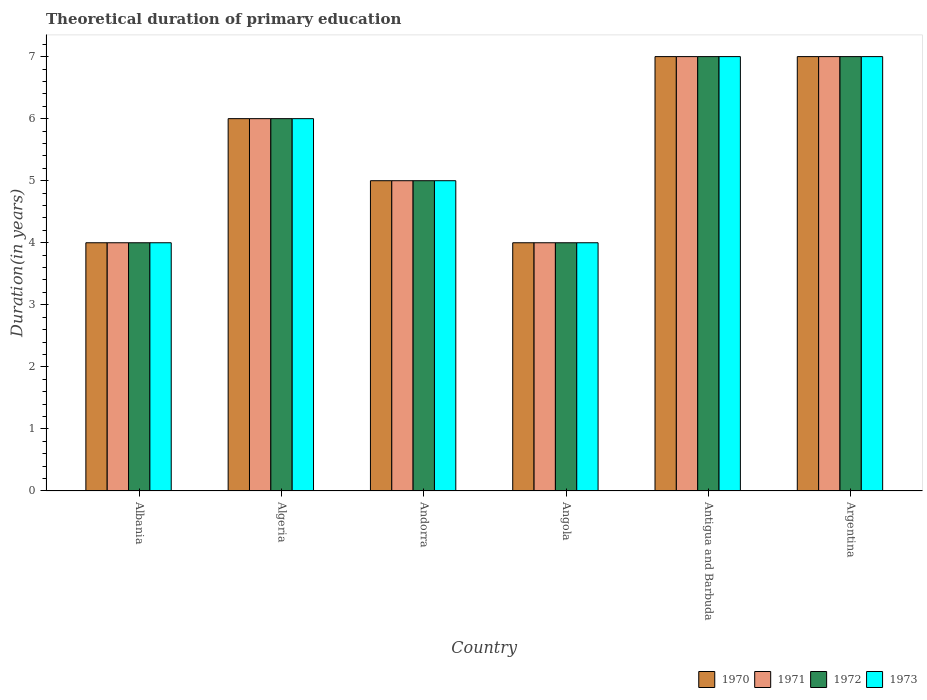How many different coloured bars are there?
Your answer should be compact. 4. Are the number of bars per tick equal to the number of legend labels?
Provide a succinct answer. Yes. How many bars are there on the 6th tick from the left?
Your response must be concise. 4. How many bars are there on the 5th tick from the right?
Your answer should be compact. 4. What is the label of the 2nd group of bars from the left?
Offer a very short reply. Algeria. Across all countries, what is the maximum total theoretical duration of primary education in 1971?
Offer a very short reply. 7. In which country was the total theoretical duration of primary education in 1972 maximum?
Provide a short and direct response. Antigua and Barbuda. In which country was the total theoretical duration of primary education in 1972 minimum?
Offer a terse response. Albania. What is the difference between the total theoretical duration of primary education in 1970 in Argentina and the total theoretical duration of primary education in 1972 in Algeria?
Your answer should be compact. 1. In how many countries, is the total theoretical duration of primary education in 1972 greater than 6.8 years?
Provide a succinct answer. 2. What is the ratio of the total theoretical duration of primary education in 1973 in Algeria to that in Antigua and Barbuda?
Offer a very short reply. 0.86. Is the total theoretical duration of primary education in 1973 in Albania less than that in Argentina?
Ensure brevity in your answer.  Yes. Is the difference between the total theoretical duration of primary education in 1971 in Albania and Argentina greater than the difference between the total theoretical duration of primary education in 1970 in Albania and Argentina?
Provide a short and direct response. No. What is the difference between the highest and the second highest total theoretical duration of primary education in 1970?
Ensure brevity in your answer.  -1. What is the difference between the highest and the lowest total theoretical duration of primary education in 1973?
Make the answer very short. 3. Is the sum of the total theoretical duration of primary education in 1973 in Algeria and Antigua and Barbuda greater than the maximum total theoretical duration of primary education in 1971 across all countries?
Offer a terse response. Yes. What does the 1st bar from the left in Albania represents?
Your response must be concise. 1970. What does the 2nd bar from the right in Argentina represents?
Make the answer very short. 1972. How many bars are there?
Your answer should be compact. 24. Are all the bars in the graph horizontal?
Provide a short and direct response. No. What is the difference between two consecutive major ticks on the Y-axis?
Make the answer very short. 1. Are the values on the major ticks of Y-axis written in scientific E-notation?
Offer a terse response. No. Where does the legend appear in the graph?
Keep it short and to the point. Bottom right. How many legend labels are there?
Make the answer very short. 4. How are the legend labels stacked?
Provide a succinct answer. Horizontal. What is the title of the graph?
Your response must be concise. Theoretical duration of primary education. What is the label or title of the X-axis?
Provide a short and direct response. Country. What is the label or title of the Y-axis?
Offer a very short reply. Duration(in years). What is the Duration(in years) in 1970 in Albania?
Your answer should be compact. 4. What is the Duration(in years) of 1971 in Albania?
Keep it short and to the point. 4. What is the Duration(in years) in 1973 in Albania?
Offer a terse response. 4. What is the Duration(in years) in 1972 in Algeria?
Offer a terse response. 6. What is the Duration(in years) of 1973 in Algeria?
Keep it short and to the point. 6. What is the Duration(in years) in 1971 in Andorra?
Make the answer very short. 5. What is the Duration(in years) of 1972 in Andorra?
Offer a very short reply. 5. What is the Duration(in years) of 1970 in Angola?
Make the answer very short. 4. What is the Duration(in years) in 1972 in Angola?
Give a very brief answer. 4. What is the Duration(in years) in 1973 in Angola?
Your answer should be compact. 4. What is the Duration(in years) of 1971 in Antigua and Barbuda?
Provide a succinct answer. 7. What is the Duration(in years) in 1970 in Argentina?
Offer a very short reply. 7. What is the Duration(in years) in 1973 in Argentina?
Make the answer very short. 7. Across all countries, what is the maximum Duration(in years) in 1973?
Make the answer very short. 7. Across all countries, what is the minimum Duration(in years) of 1971?
Keep it short and to the point. 4. What is the total Duration(in years) of 1970 in the graph?
Your answer should be compact. 33. What is the total Duration(in years) in 1973 in the graph?
Offer a terse response. 33. What is the difference between the Duration(in years) in 1970 in Albania and that in Algeria?
Make the answer very short. -2. What is the difference between the Duration(in years) of 1971 in Albania and that in Algeria?
Your answer should be compact. -2. What is the difference between the Duration(in years) in 1972 in Albania and that in Algeria?
Give a very brief answer. -2. What is the difference between the Duration(in years) in 1973 in Albania and that in Algeria?
Your answer should be very brief. -2. What is the difference between the Duration(in years) in 1970 in Albania and that in Andorra?
Make the answer very short. -1. What is the difference between the Duration(in years) of 1973 in Albania and that in Andorra?
Your response must be concise. -1. What is the difference between the Duration(in years) in 1971 in Albania and that in Angola?
Your response must be concise. 0. What is the difference between the Duration(in years) in 1971 in Albania and that in Antigua and Barbuda?
Your answer should be compact. -3. What is the difference between the Duration(in years) of 1972 in Albania and that in Antigua and Barbuda?
Offer a terse response. -3. What is the difference between the Duration(in years) in 1971 in Albania and that in Argentina?
Provide a short and direct response. -3. What is the difference between the Duration(in years) in 1970 in Algeria and that in Andorra?
Offer a terse response. 1. What is the difference between the Duration(in years) of 1972 in Algeria and that in Andorra?
Offer a terse response. 1. What is the difference between the Duration(in years) of 1970 in Algeria and that in Angola?
Ensure brevity in your answer.  2. What is the difference between the Duration(in years) of 1970 in Algeria and that in Antigua and Barbuda?
Provide a short and direct response. -1. What is the difference between the Duration(in years) in 1972 in Algeria and that in Antigua and Barbuda?
Keep it short and to the point. -1. What is the difference between the Duration(in years) in 1973 in Algeria and that in Antigua and Barbuda?
Your answer should be compact. -1. What is the difference between the Duration(in years) in 1970 in Algeria and that in Argentina?
Your response must be concise. -1. What is the difference between the Duration(in years) of 1971 in Algeria and that in Argentina?
Make the answer very short. -1. What is the difference between the Duration(in years) of 1972 in Algeria and that in Argentina?
Make the answer very short. -1. What is the difference between the Duration(in years) in 1972 in Andorra and that in Angola?
Make the answer very short. 1. What is the difference between the Duration(in years) of 1970 in Andorra and that in Antigua and Barbuda?
Keep it short and to the point. -2. What is the difference between the Duration(in years) of 1972 in Andorra and that in Antigua and Barbuda?
Offer a terse response. -2. What is the difference between the Duration(in years) in 1973 in Andorra and that in Antigua and Barbuda?
Your answer should be very brief. -2. What is the difference between the Duration(in years) of 1971 in Andorra and that in Argentina?
Keep it short and to the point. -2. What is the difference between the Duration(in years) in 1972 in Andorra and that in Argentina?
Offer a very short reply. -2. What is the difference between the Duration(in years) in 1970 in Angola and that in Antigua and Barbuda?
Your response must be concise. -3. What is the difference between the Duration(in years) in 1973 in Angola and that in Antigua and Barbuda?
Your answer should be very brief. -3. What is the difference between the Duration(in years) of 1971 in Angola and that in Argentina?
Keep it short and to the point. -3. What is the difference between the Duration(in years) of 1972 in Angola and that in Argentina?
Ensure brevity in your answer.  -3. What is the difference between the Duration(in years) of 1973 in Angola and that in Argentina?
Give a very brief answer. -3. What is the difference between the Duration(in years) in 1972 in Albania and the Duration(in years) in 1973 in Algeria?
Your answer should be compact. -2. What is the difference between the Duration(in years) in 1970 in Albania and the Duration(in years) in 1971 in Andorra?
Make the answer very short. -1. What is the difference between the Duration(in years) in 1971 in Albania and the Duration(in years) in 1972 in Andorra?
Make the answer very short. -1. What is the difference between the Duration(in years) of 1970 in Albania and the Duration(in years) of 1972 in Angola?
Ensure brevity in your answer.  0. What is the difference between the Duration(in years) of 1971 in Albania and the Duration(in years) of 1973 in Angola?
Offer a very short reply. 0. What is the difference between the Duration(in years) in 1972 in Albania and the Duration(in years) in 1973 in Angola?
Your answer should be compact. 0. What is the difference between the Duration(in years) of 1970 in Albania and the Duration(in years) of 1971 in Antigua and Barbuda?
Offer a very short reply. -3. What is the difference between the Duration(in years) of 1970 in Albania and the Duration(in years) of 1973 in Antigua and Barbuda?
Keep it short and to the point. -3. What is the difference between the Duration(in years) in 1970 in Albania and the Duration(in years) in 1971 in Argentina?
Make the answer very short. -3. What is the difference between the Duration(in years) in 1970 in Albania and the Duration(in years) in 1973 in Argentina?
Ensure brevity in your answer.  -3. What is the difference between the Duration(in years) in 1971 in Albania and the Duration(in years) in 1972 in Argentina?
Your answer should be very brief. -3. What is the difference between the Duration(in years) in 1970 in Algeria and the Duration(in years) in 1971 in Andorra?
Provide a short and direct response. 1. What is the difference between the Duration(in years) of 1971 in Algeria and the Duration(in years) of 1973 in Andorra?
Keep it short and to the point. 1. What is the difference between the Duration(in years) in 1970 in Algeria and the Duration(in years) in 1971 in Angola?
Ensure brevity in your answer.  2. What is the difference between the Duration(in years) in 1970 in Algeria and the Duration(in years) in 1973 in Angola?
Your answer should be very brief. 2. What is the difference between the Duration(in years) in 1971 in Algeria and the Duration(in years) in 1972 in Angola?
Your answer should be compact. 2. What is the difference between the Duration(in years) in 1971 in Algeria and the Duration(in years) in 1973 in Angola?
Provide a short and direct response. 2. What is the difference between the Duration(in years) in 1972 in Algeria and the Duration(in years) in 1973 in Angola?
Offer a very short reply. 2. What is the difference between the Duration(in years) in 1970 in Algeria and the Duration(in years) in 1971 in Antigua and Barbuda?
Make the answer very short. -1. What is the difference between the Duration(in years) in 1971 in Algeria and the Duration(in years) in 1972 in Antigua and Barbuda?
Keep it short and to the point. -1. What is the difference between the Duration(in years) in 1971 in Algeria and the Duration(in years) in 1973 in Antigua and Barbuda?
Offer a very short reply. -1. What is the difference between the Duration(in years) in 1970 in Algeria and the Duration(in years) in 1971 in Argentina?
Give a very brief answer. -1. What is the difference between the Duration(in years) of 1970 in Algeria and the Duration(in years) of 1972 in Argentina?
Make the answer very short. -1. What is the difference between the Duration(in years) of 1970 in Algeria and the Duration(in years) of 1973 in Argentina?
Your answer should be compact. -1. What is the difference between the Duration(in years) of 1971 in Algeria and the Duration(in years) of 1973 in Argentina?
Keep it short and to the point. -1. What is the difference between the Duration(in years) of 1972 in Algeria and the Duration(in years) of 1973 in Argentina?
Keep it short and to the point. -1. What is the difference between the Duration(in years) in 1970 in Andorra and the Duration(in years) in 1971 in Angola?
Your answer should be very brief. 1. What is the difference between the Duration(in years) of 1970 in Andorra and the Duration(in years) of 1972 in Angola?
Your answer should be compact. 1. What is the difference between the Duration(in years) of 1970 in Andorra and the Duration(in years) of 1973 in Angola?
Your answer should be very brief. 1. What is the difference between the Duration(in years) of 1972 in Andorra and the Duration(in years) of 1973 in Angola?
Provide a succinct answer. 1. What is the difference between the Duration(in years) of 1970 in Andorra and the Duration(in years) of 1973 in Antigua and Barbuda?
Make the answer very short. -2. What is the difference between the Duration(in years) of 1971 in Andorra and the Duration(in years) of 1972 in Antigua and Barbuda?
Make the answer very short. -2. What is the difference between the Duration(in years) in 1972 in Andorra and the Duration(in years) in 1973 in Antigua and Barbuda?
Offer a very short reply. -2. What is the difference between the Duration(in years) in 1970 in Andorra and the Duration(in years) in 1971 in Argentina?
Ensure brevity in your answer.  -2. What is the difference between the Duration(in years) of 1970 in Andorra and the Duration(in years) of 1972 in Argentina?
Ensure brevity in your answer.  -2. What is the difference between the Duration(in years) of 1970 in Angola and the Duration(in years) of 1971 in Antigua and Barbuda?
Offer a terse response. -3. What is the difference between the Duration(in years) of 1970 in Angola and the Duration(in years) of 1972 in Antigua and Barbuda?
Your response must be concise. -3. What is the difference between the Duration(in years) of 1972 in Angola and the Duration(in years) of 1973 in Antigua and Barbuda?
Keep it short and to the point. -3. What is the difference between the Duration(in years) of 1970 in Angola and the Duration(in years) of 1971 in Argentina?
Your answer should be compact. -3. What is the difference between the Duration(in years) in 1970 in Antigua and Barbuda and the Duration(in years) in 1972 in Argentina?
Ensure brevity in your answer.  0. What is the difference between the Duration(in years) of 1972 in Antigua and Barbuda and the Duration(in years) of 1973 in Argentina?
Offer a very short reply. 0. What is the average Duration(in years) in 1970 per country?
Offer a very short reply. 5.5. What is the average Duration(in years) of 1972 per country?
Offer a very short reply. 5.5. What is the average Duration(in years) in 1973 per country?
Offer a terse response. 5.5. What is the difference between the Duration(in years) in 1970 and Duration(in years) in 1971 in Albania?
Your answer should be compact. 0. What is the difference between the Duration(in years) in 1970 and Duration(in years) in 1972 in Albania?
Provide a short and direct response. 0. What is the difference between the Duration(in years) in 1971 and Duration(in years) in 1972 in Albania?
Offer a terse response. 0. What is the difference between the Duration(in years) of 1971 and Duration(in years) of 1973 in Albania?
Your answer should be compact. 0. What is the difference between the Duration(in years) in 1972 and Duration(in years) in 1973 in Albania?
Make the answer very short. 0. What is the difference between the Duration(in years) of 1971 and Duration(in years) of 1972 in Algeria?
Provide a short and direct response. 0. What is the difference between the Duration(in years) of 1971 and Duration(in years) of 1973 in Algeria?
Give a very brief answer. 0. What is the difference between the Duration(in years) of 1970 and Duration(in years) of 1973 in Andorra?
Provide a short and direct response. 0. What is the difference between the Duration(in years) in 1971 and Duration(in years) in 1972 in Andorra?
Ensure brevity in your answer.  0. What is the difference between the Duration(in years) in 1972 and Duration(in years) in 1973 in Andorra?
Your response must be concise. 0. What is the difference between the Duration(in years) of 1970 and Duration(in years) of 1971 in Angola?
Ensure brevity in your answer.  0. What is the difference between the Duration(in years) in 1970 and Duration(in years) in 1972 in Angola?
Make the answer very short. 0. What is the difference between the Duration(in years) in 1970 and Duration(in years) in 1973 in Angola?
Your response must be concise. 0. What is the difference between the Duration(in years) of 1971 and Duration(in years) of 1972 in Angola?
Keep it short and to the point. 0. What is the difference between the Duration(in years) of 1971 and Duration(in years) of 1973 in Angola?
Your answer should be very brief. 0. What is the difference between the Duration(in years) in 1970 and Duration(in years) in 1973 in Antigua and Barbuda?
Give a very brief answer. 0. What is the difference between the Duration(in years) of 1970 and Duration(in years) of 1971 in Argentina?
Your answer should be compact. 0. What is the difference between the Duration(in years) in 1970 and Duration(in years) in 1972 in Argentina?
Ensure brevity in your answer.  0. What is the ratio of the Duration(in years) in 1970 in Albania to that in Algeria?
Ensure brevity in your answer.  0.67. What is the ratio of the Duration(in years) in 1972 in Albania to that in Algeria?
Your answer should be very brief. 0.67. What is the ratio of the Duration(in years) in 1970 in Albania to that in Andorra?
Your response must be concise. 0.8. What is the ratio of the Duration(in years) of 1973 in Albania to that in Andorra?
Your response must be concise. 0.8. What is the ratio of the Duration(in years) in 1970 in Albania to that in Angola?
Give a very brief answer. 1. What is the ratio of the Duration(in years) in 1973 in Albania to that in Angola?
Give a very brief answer. 1. What is the ratio of the Duration(in years) in 1970 in Albania to that in Antigua and Barbuda?
Your response must be concise. 0.57. What is the ratio of the Duration(in years) of 1973 in Albania to that in Antigua and Barbuda?
Your answer should be compact. 0.57. What is the ratio of the Duration(in years) in 1970 in Albania to that in Argentina?
Your answer should be very brief. 0.57. What is the ratio of the Duration(in years) in 1971 in Albania to that in Argentina?
Your answer should be compact. 0.57. What is the ratio of the Duration(in years) of 1972 in Algeria to that in Angola?
Offer a terse response. 1.5. What is the ratio of the Duration(in years) in 1973 in Algeria to that in Angola?
Offer a very short reply. 1.5. What is the ratio of the Duration(in years) in 1972 in Algeria to that in Antigua and Barbuda?
Your answer should be compact. 0.86. What is the ratio of the Duration(in years) of 1970 in Algeria to that in Argentina?
Make the answer very short. 0.86. What is the ratio of the Duration(in years) of 1970 in Andorra to that in Angola?
Give a very brief answer. 1.25. What is the ratio of the Duration(in years) in 1971 in Andorra to that in Angola?
Your answer should be compact. 1.25. What is the ratio of the Duration(in years) in 1972 in Andorra to that in Angola?
Ensure brevity in your answer.  1.25. What is the ratio of the Duration(in years) in 1972 in Andorra to that in Antigua and Barbuda?
Your answer should be very brief. 0.71. What is the ratio of the Duration(in years) in 1970 in Andorra to that in Argentina?
Ensure brevity in your answer.  0.71. What is the ratio of the Duration(in years) of 1972 in Angola to that in Antigua and Barbuda?
Give a very brief answer. 0.57. What is the ratio of the Duration(in years) of 1970 in Angola to that in Argentina?
Ensure brevity in your answer.  0.57. What is the ratio of the Duration(in years) of 1971 in Angola to that in Argentina?
Keep it short and to the point. 0.57. What is the ratio of the Duration(in years) of 1972 in Angola to that in Argentina?
Your answer should be very brief. 0.57. What is the ratio of the Duration(in years) in 1973 in Angola to that in Argentina?
Your answer should be very brief. 0.57. What is the ratio of the Duration(in years) of 1971 in Antigua and Barbuda to that in Argentina?
Your answer should be very brief. 1. What is the difference between the highest and the second highest Duration(in years) in 1971?
Provide a short and direct response. 0. What is the difference between the highest and the second highest Duration(in years) of 1973?
Keep it short and to the point. 0. What is the difference between the highest and the lowest Duration(in years) of 1970?
Provide a short and direct response. 3. What is the difference between the highest and the lowest Duration(in years) in 1971?
Provide a short and direct response. 3. What is the difference between the highest and the lowest Duration(in years) in 1973?
Your response must be concise. 3. 